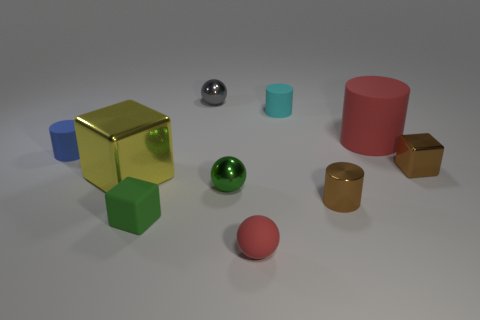How many tiny shiny objects are in front of the blue object and behind the yellow metal object?
Offer a very short reply. 1. There is a small rubber thing that is the same color as the large matte object; what is its shape?
Your answer should be very brief. Sphere. There is a block that is both to the left of the small red rubber sphere and behind the green cube; what material is it?
Your answer should be very brief. Metal. Is the number of small gray shiny things to the right of the green metal ball less than the number of red things behind the blue cylinder?
Give a very brief answer. Yes. There is another sphere that is made of the same material as the small green sphere; what size is it?
Your answer should be very brief. Small. Is there anything else of the same color as the tiny matte block?
Your response must be concise. Yes. Are the yellow cube and the green object that is on the right side of the gray sphere made of the same material?
Your answer should be very brief. Yes. What is the material of the small red thing that is the same shape as the tiny gray shiny thing?
Provide a short and direct response. Rubber. Are there any other things that are made of the same material as the small green ball?
Your answer should be compact. Yes. Do the brown object that is in front of the yellow cube and the gray thing that is behind the tiny matte block have the same material?
Ensure brevity in your answer.  Yes. 